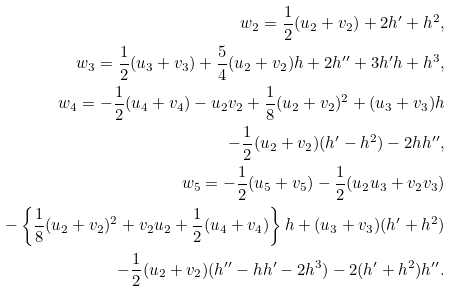Convert formula to latex. <formula><loc_0><loc_0><loc_500><loc_500>w _ { 2 } = \frac { 1 } { 2 } ( u _ { 2 } + v _ { 2 } ) + 2 h ^ { \prime } + h ^ { 2 } , \\ w _ { 3 } = \frac { 1 } { 2 } ( u _ { 3 } + v _ { 3 } ) + \frac { 5 } { 4 } ( u _ { 2 } + v _ { 2 } ) h + 2 h ^ { \prime \prime } + 3 h ^ { \prime } h + h ^ { 3 } , \\ w _ { 4 } = - \frac { 1 } { 2 } ( u _ { 4 } + v _ { 4 } ) - u _ { 2 } v _ { 2 } + \frac { 1 } { 8 } ( u _ { 2 } + v _ { 2 } ) ^ { 2 } + ( u _ { 3 } + v _ { 3 } ) h \\ \quad - \frac { 1 } { 2 } ( u _ { 2 } + v _ { 2 } ) ( h ^ { \prime } - h ^ { 2 } ) - 2 h h ^ { \prime \prime } , \\ w _ { 5 } = - \frac { 1 } { 2 } ( u _ { 5 } + v _ { 5 } ) - \frac { 1 } { 2 } ( u _ { 2 } u _ { 3 } + v _ { 2 } v _ { 3 } ) \\ \quad - \left \{ \frac { 1 } { 8 } ( u _ { 2 } + v _ { 2 } ) ^ { 2 } + v _ { 2 } u _ { 2 } + \frac { 1 } { 2 } ( u _ { 4 } + v _ { 4 } ) \right \} h + ( u _ { 3 } + v _ { 3 } ) ( h ^ { \prime } + h ^ { 2 } ) \\ \quad - \frac { 1 } { 2 } ( u _ { 2 } + v _ { 2 } ) ( h ^ { \prime \prime } - h h ^ { \prime } - 2 h ^ { 3 } ) - 2 ( h ^ { \prime } + h ^ { 2 } ) h ^ { \prime \prime } .</formula> 